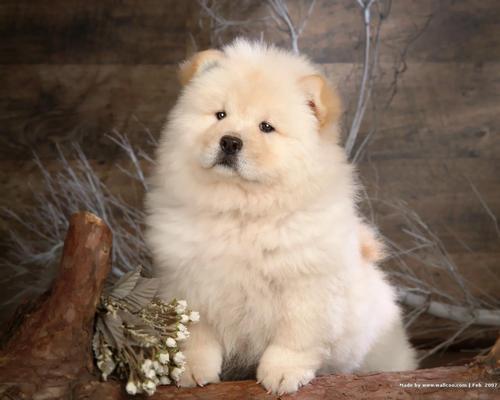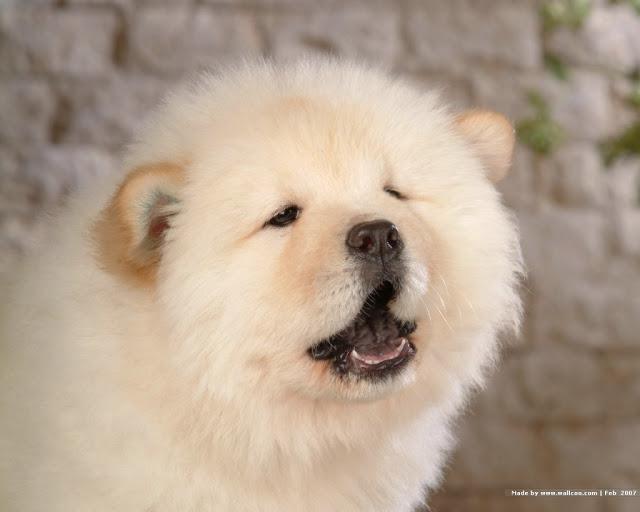The first image is the image on the left, the second image is the image on the right. For the images shown, is this caption "In one image, a small white dog is beside driftwood and in front of a wooden wall." true? Answer yes or no. Yes. The first image is the image on the left, the second image is the image on the right. Assess this claim about the two images: "An image shows three chow pups on a plush surface.". Correct or not? Answer yes or no. No. 